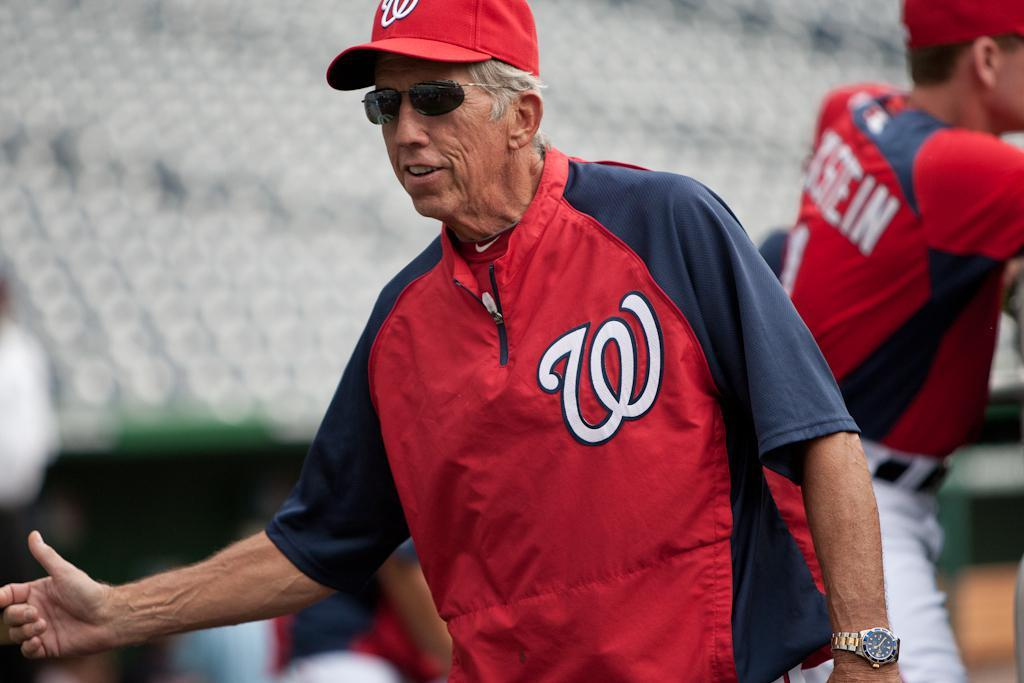Who is the main subject in the image? There is an old man in the image. What is the old man wearing? The old man is wearing a red jacket and a red cap. What is the old man doing in the image? The old man is raising his hand. Can you describe the other person in the image? There is another man in the background of the image. What type of honey is the old man using to eat his meal in the image? There is no honey present in the image, and the old man is not shown eating a meal. 